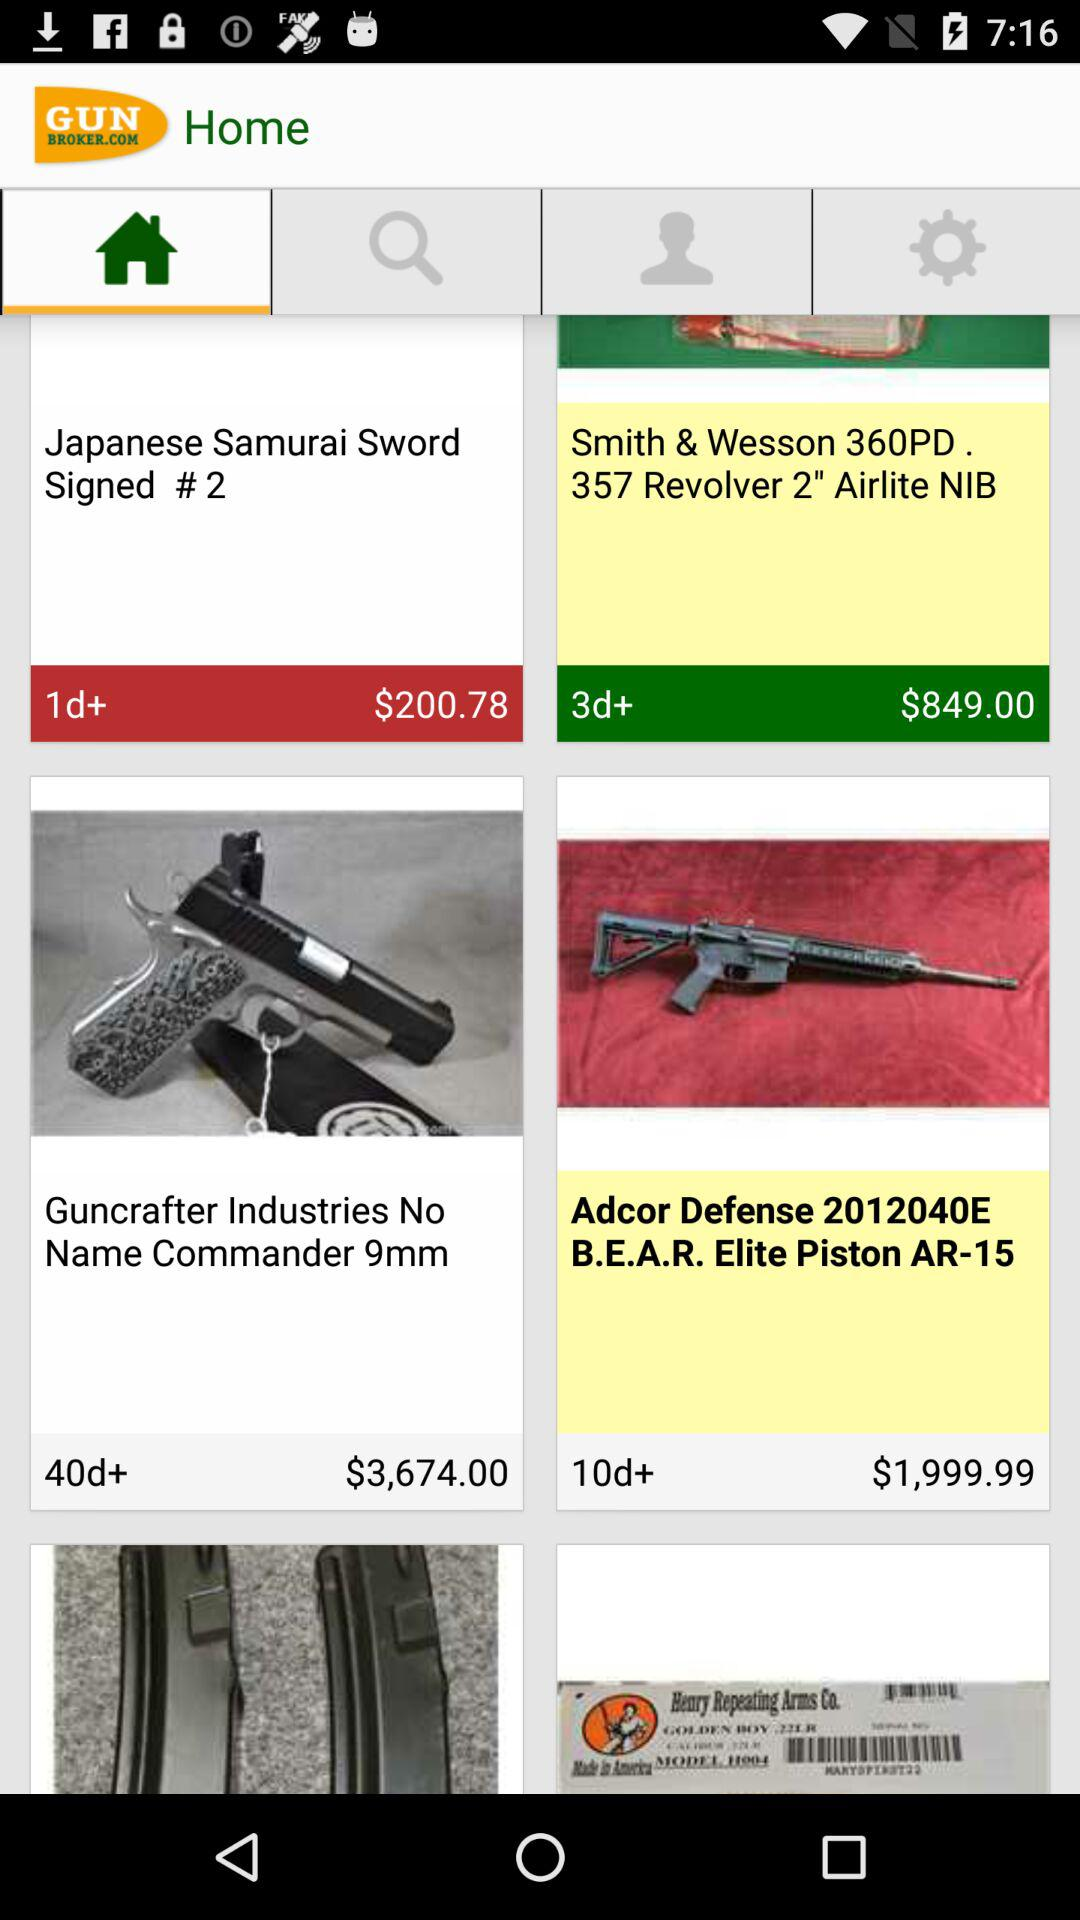Which tab has been selected? The selected tab is "Home". 